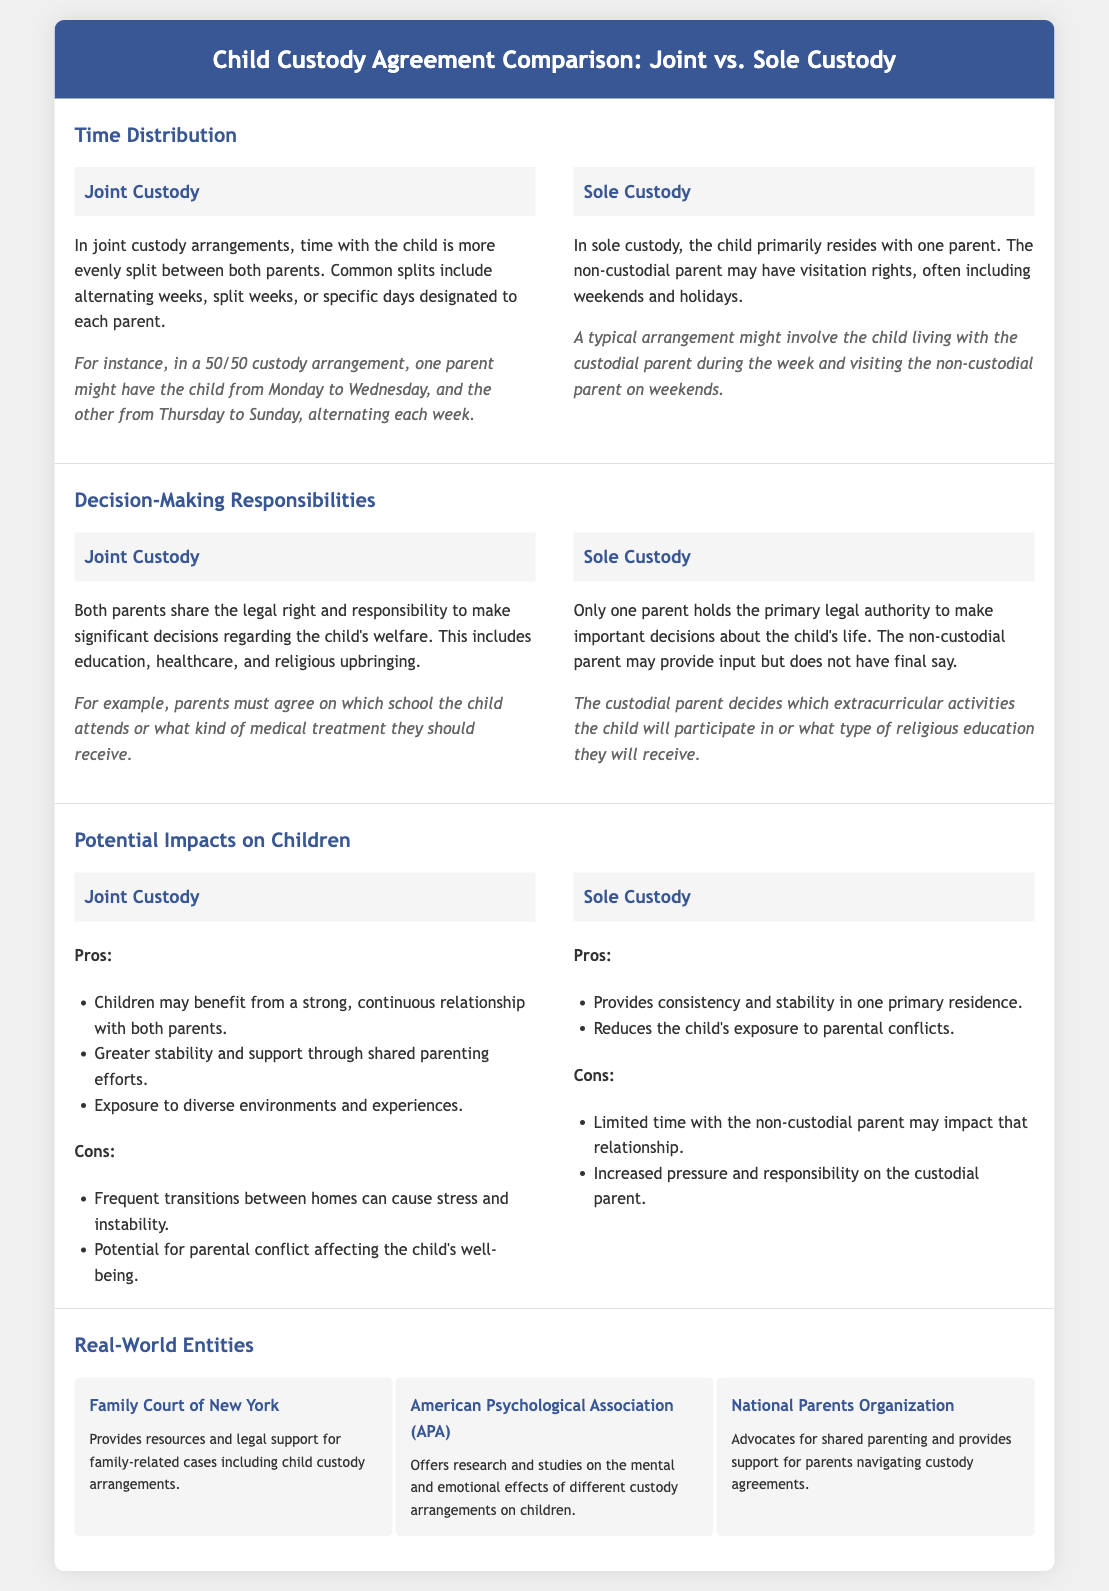What is a typical arrangement for Sole Custody? The document describes a typical arrangement as the child living with the custodial parent during the week and visiting the non-custodial parent on weekends.
Answer: Living with the custodial parent during the week, visiting on weekends What is the primary legal authority in Sole Custody? The document states that only one parent holds the primary legal authority to make important decisions about the child's life in Sole Custody.
Answer: One parent What are the pros of Joint Custody? The document lists benefits of Joint Custody such as a strong relationship with both parents, greater stability, and exposure to diverse experiences.
Answer: Strong relationship, greater stability, diverse experiences What does the American Psychological Association (APA) provide? According to the document, the APA offers research and studies on the mental and emotional effects of different custody arrangements on children.
Answer: Research and studies on custody effects What is a common time split in Joint Custody? The document provides an example of a common time split in Joint Custody as alternating weeks, split weeks, or specific days designated to each parent.
Answer: Alternating weeks What is a con of Sole Custody? The document lists a con of Sole Custody as limited time with the non-custodial parent, which may impact that relationship.
Answer: Limited time with non-custodial parent What do parents need to agree on in Joint Custody? The document specifies that parents must agree on significant decisions such as education, healthcare, and religious upbringing in Joint Custody.
Answer: Education, healthcare, religious upbringing What organization advocates for shared parenting? The document mentions the National Parents Organization as an entity that advocates for shared parenting.
Answer: National Parents Organization 